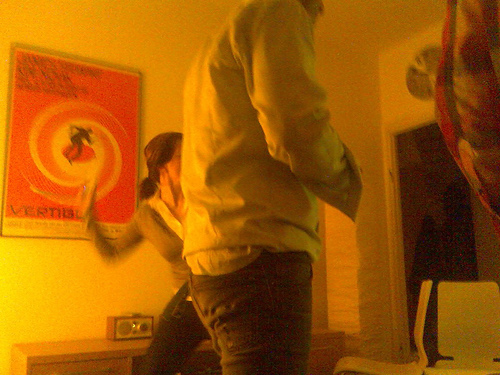How many chairs are visible? There are two chairs visible in the room, one partially obscured behind the individual standing in the foreground, and another more clearly visible to their side. 